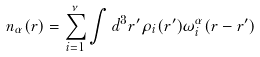<formula> <loc_0><loc_0><loc_500><loc_500>n _ { \alpha } ( { r } ) = \sum _ { i = 1 } ^ { \nu } \int d ^ { 3 } r ^ { \prime } \rho _ { i } ( { r } ^ { \prime } ) \omega _ { i } ^ { \alpha } ( { r } - { r } ^ { \prime } )</formula> 